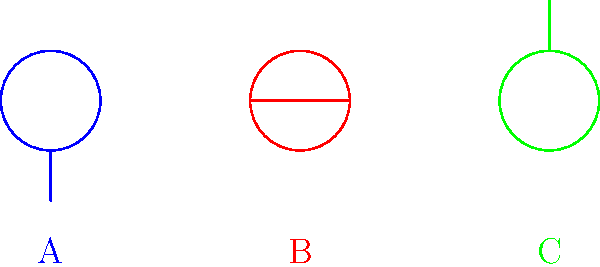Based on the diagram, which type of oral piercing is represented by label B? To identify the type of oral piercing represented by label B, let's analyze the diagram step-by-step:

1. The diagram shows three different oral piercings, labeled A, B, and C.
2. Label A (blue) shows a circle with a line extending downward, representing a lip piercing.
3. Label B (red) shows a circle with a horizontal line passing through it.
4. Label C (green) shows a circle with a line extending upward, representing a labret piercing.
5. The horizontal line passing through the circle in label B is characteristic of a tongue piercing.
6. Tongue piercings typically have a barbell that runs horizontally through the tongue, which matches the representation in the diagram.

Therefore, the oral piercing represented by label B is a tongue piercing.
Answer: Tongue piercing 